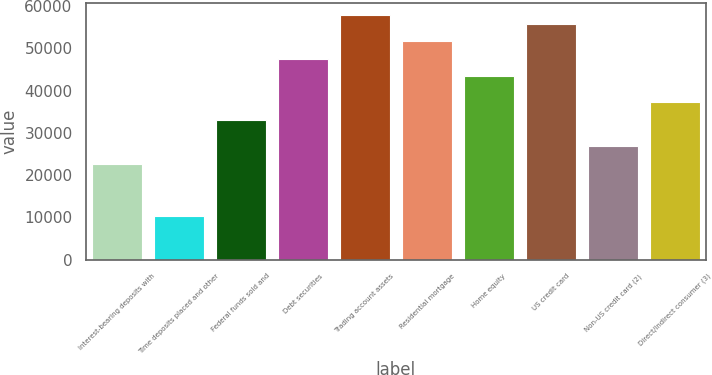Convert chart to OTSL. <chart><loc_0><loc_0><loc_500><loc_500><bar_chart><fcel>Interest-bearing deposits with<fcel>Time deposits placed and other<fcel>Federal funds sold and<fcel>Debt securities<fcel>Trading account assets<fcel>Residential mortgage<fcel>Home equity<fcel>US credit card<fcel>Non-US credit card (2)<fcel>Direct/Indirect consumer (3)<nl><fcel>22734.3<fcel>10336.5<fcel>33065.8<fcel>47529.9<fcel>57861.4<fcel>51662.5<fcel>43397.3<fcel>55795.1<fcel>26866.9<fcel>37198.4<nl></chart> 